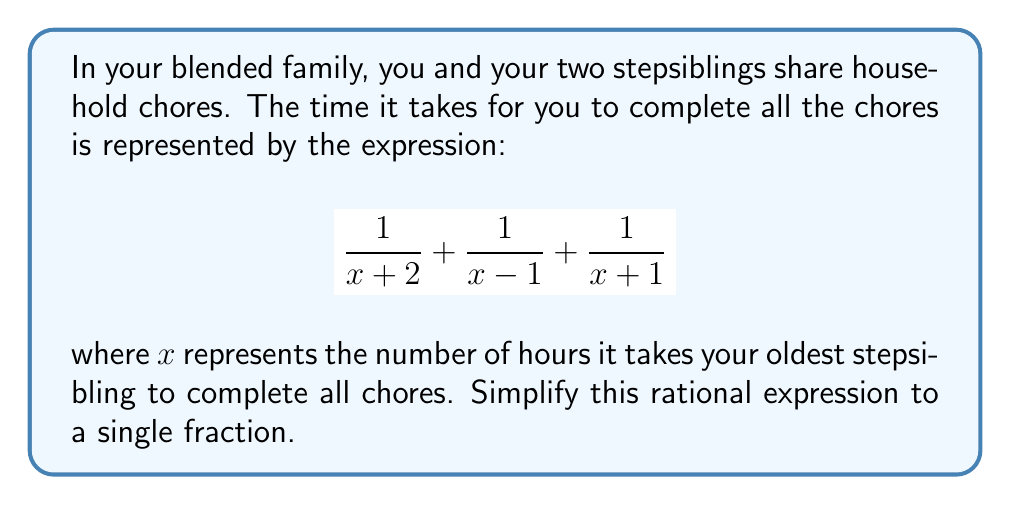Show me your answer to this math problem. Let's simplify this rational expression step-by-step:

1) First, we need to find a common denominator. The least common multiple of $(x+2)$, $(x-1)$, and $(x+1)$ is $(x+2)(x-1)(x+1)$.

2) Multiply each fraction by the appropriate factor to achieve this common denominator:

   $$\frac{(x-1)(x+1)}{(x+2)(x-1)(x+1)} + \frac{(x+2)(x+1)}{(x+2)(x-1)(x+1)} + \frac{(x+2)(x-1)}{(x+2)(x-1)(x+1)}$$

3) Simplify the numerators:

   $$\frac{x^2-1}{(x+2)(x-1)(x+1)} + \frac{x^2+3x+2}{(x+2)(x-1)(x+1)} + \frac{x^2+x-2}{(x+2)(x-1)(x+1)}$$

4) Add the numerators:

   $$\frac{x^2-1 + x^2+3x+2 + x^2+x-2}{(x+2)(x-1)(x+1)}$$

5) Simplify the numerator:

   $$\frac{3x^2+4x-1}{(x+2)(x-1)(x+1)}$$

This is the simplified rational expression.
Answer: $$\frac{3x^2+4x-1}{(x+2)(x-1)(x+1)}$$ 